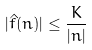<formula> <loc_0><loc_0><loc_500><loc_500>| \hat { f } ( n ) | \leq \frac { K } { | n | }</formula> 